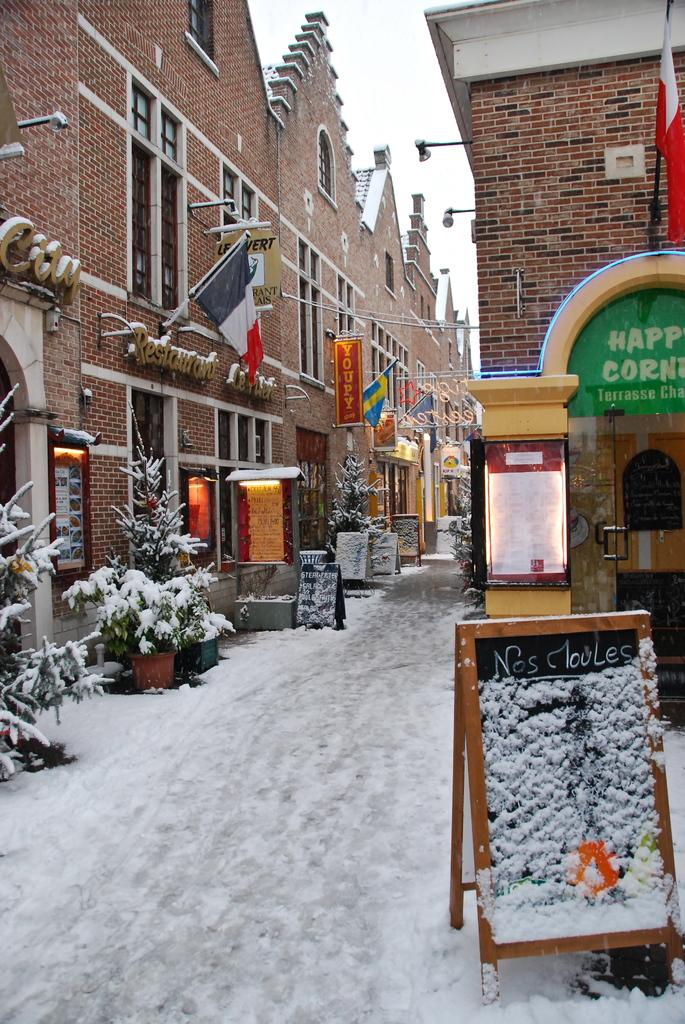What type of structures are present in the image? There are buildings in the image. What feature do the buildings have? The buildings have windows. What additional objects can be seen in the image? There are flags, boards, and plants in the image. What is the condition of the ground in the image? There is snow on the floor in the image. Where is the basin located in the image? There is no basin present in the image. What type of sugar is being used to sweeten the plants in the image? There is no sugar or indication of sweetening the plants in the image. 